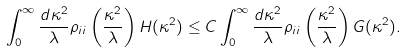Convert formula to latex. <formula><loc_0><loc_0><loc_500><loc_500>\int _ { 0 } ^ { \infty } \frac { d \kappa ^ { 2 } } { \lambda } \rho _ { i i } \left ( \frac { \kappa ^ { 2 } } { \lambda } \right ) H ( \kappa ^ { 2 } ) \leq C \int _ { 0 } ^ { \infty } \frac { d \kappa ^ { 2 } } { \lambda } \rho _ { i i } \left ( \frac { \kappa ^ { 2 } } { \lambda } \right ) G ( \kappa ^ { 2 } ) .</formula> 